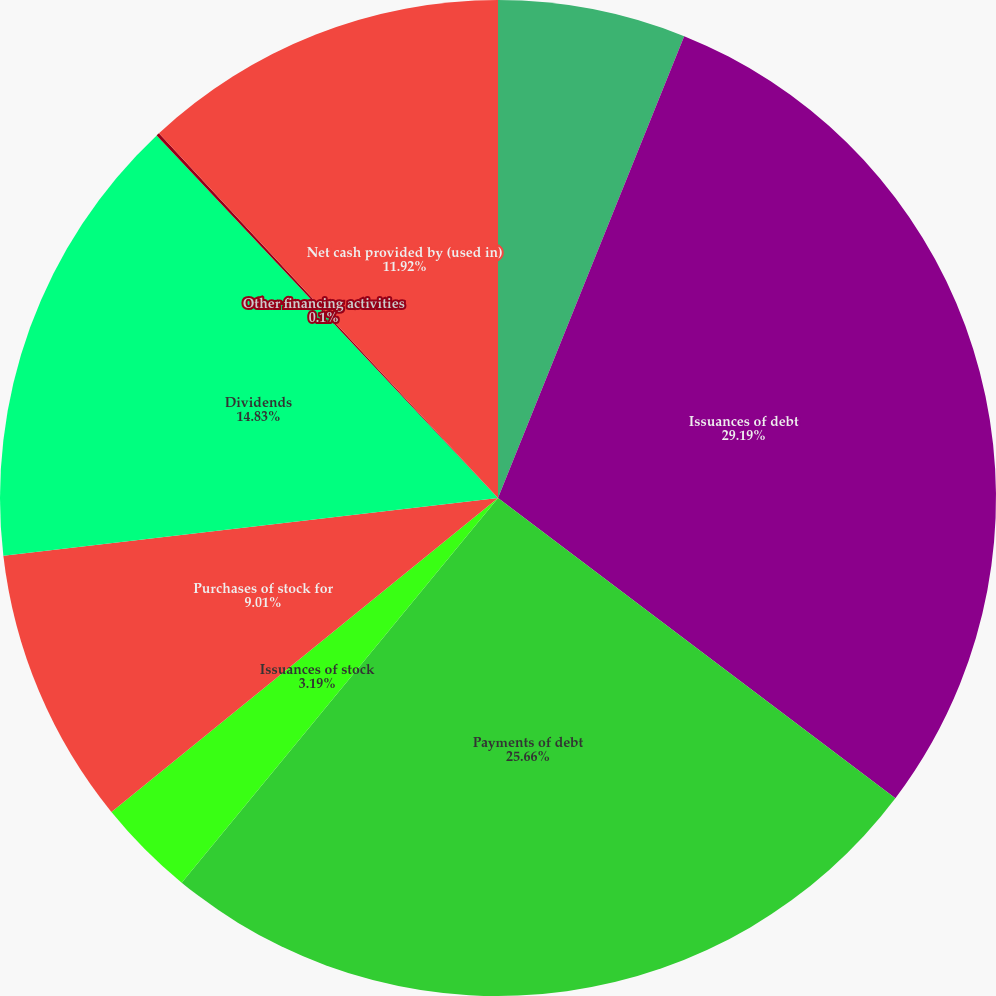<chart> <loc_0><loc_0><loc_500><loc_500><pie_chart><fcel>Year Ended December 31<fcel>Issuances of debt<fcel>Payments of debt<fcel>Issuances of stock<fcel>Purchases of stock for<fcel>Dividends<fcel>Other financing activities<fcel>Net cash provided by (used in)<nl><fcel>6.1%<fcel>29.2%<fcel>25.66%<fcel>3.19%<fcel>9.01%<fcel>14.83%<fcel>0.1%<fcel>11.92%<nl></chart> 